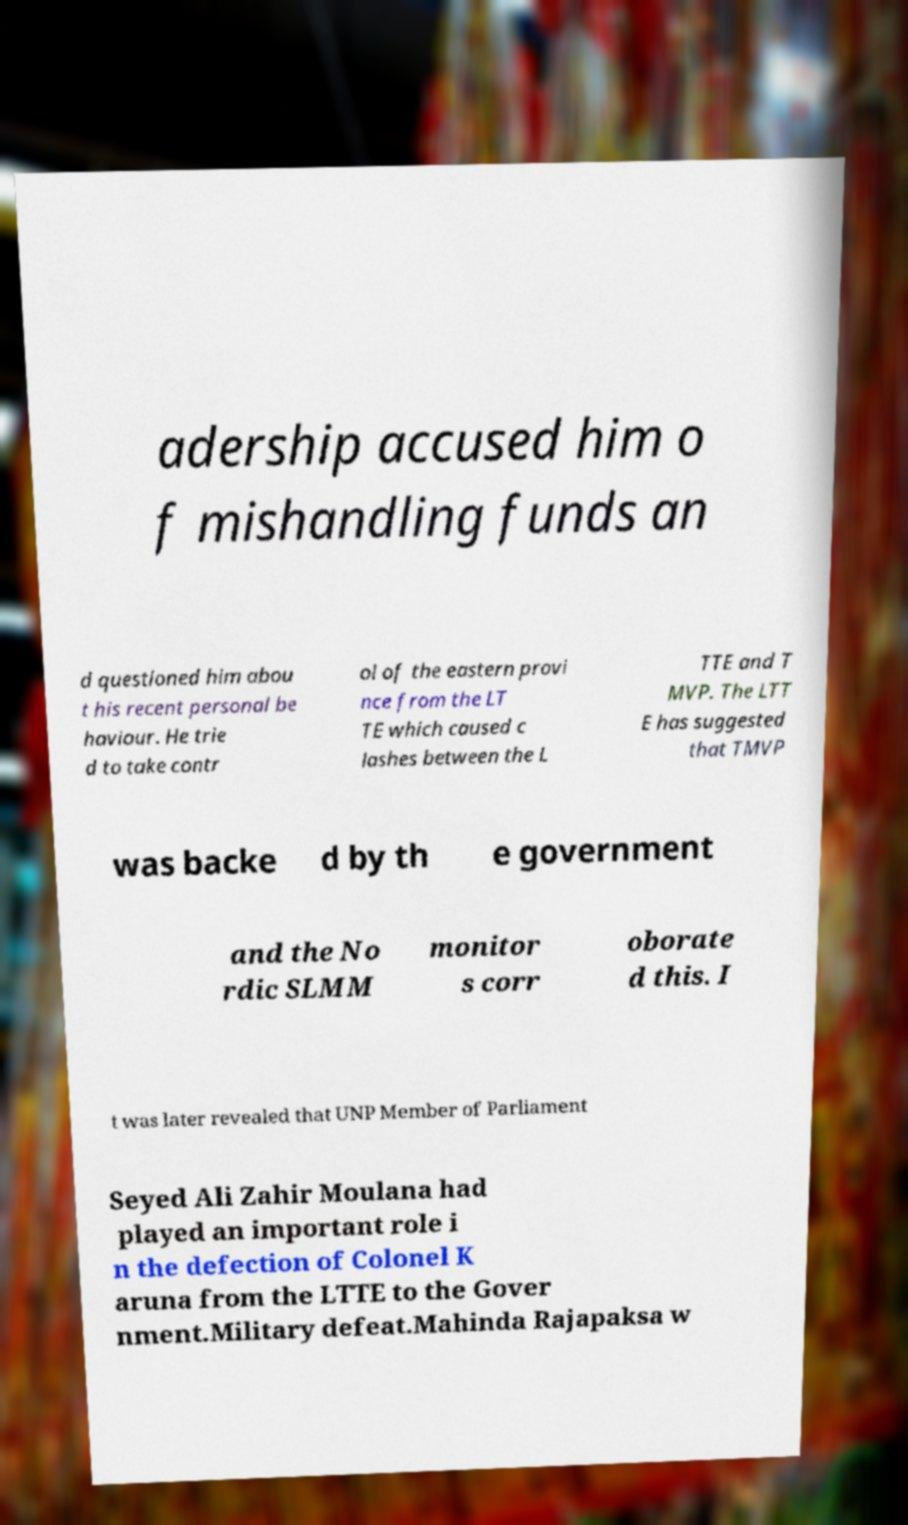What messages or text are displayed in this image? I need them in a readable, typed format. adership accused him o f mishandling funds an d questioned him abou t his recent personal be haviour. He trie d to take contr ol of the eastern provi nce from the LT TE which caused c lashes between the L TTE and T MVP. The LTT E has suggested that TMVP was backe d by th e government and the No rdic SLMM monitor s corr oborate d this. I t was later revealed that UNP Member of Parliament Seyed Ali Zahir Moulana had played an important role i n the defection of Colonel K aruna from the LTTE to the Gover nment.Military defeat.Mahinda Rajapaksa w 